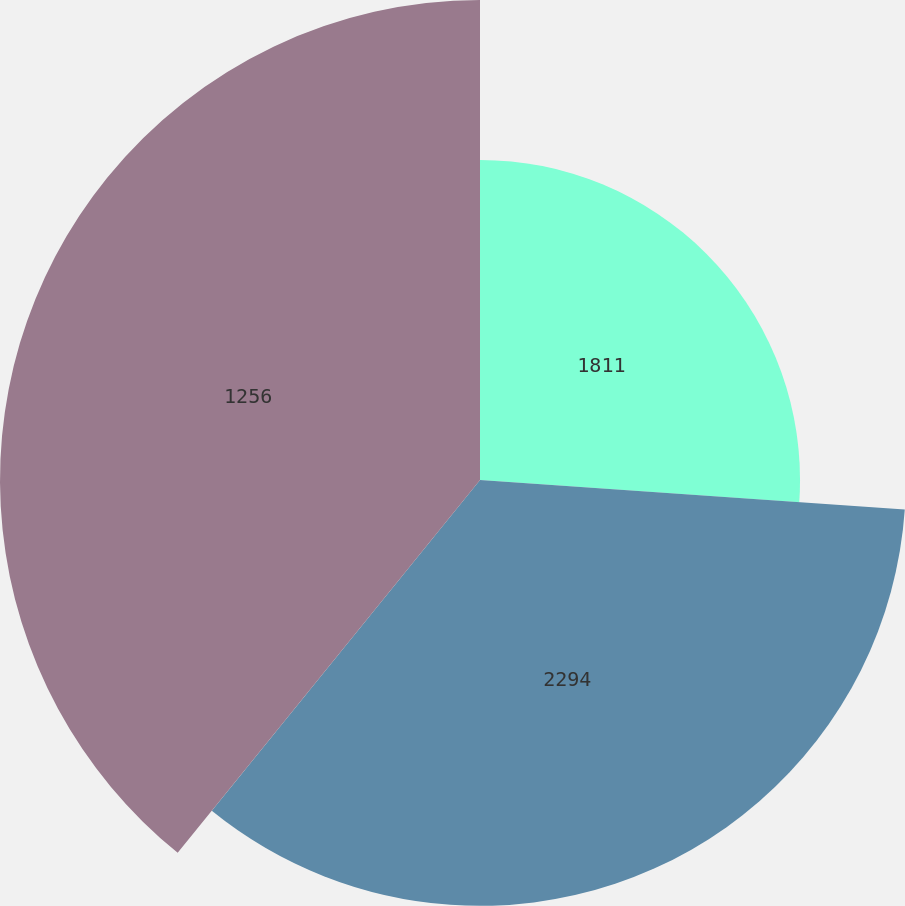Convert chart. <chart><loc_0><loc_0><loc_500><loc_500><pie_chart><fcel>1811<fcel>2294<fcel>1256<nl><fcel>26.11%<fcel>34.74%<fcel>39.16%<nl></chart> 